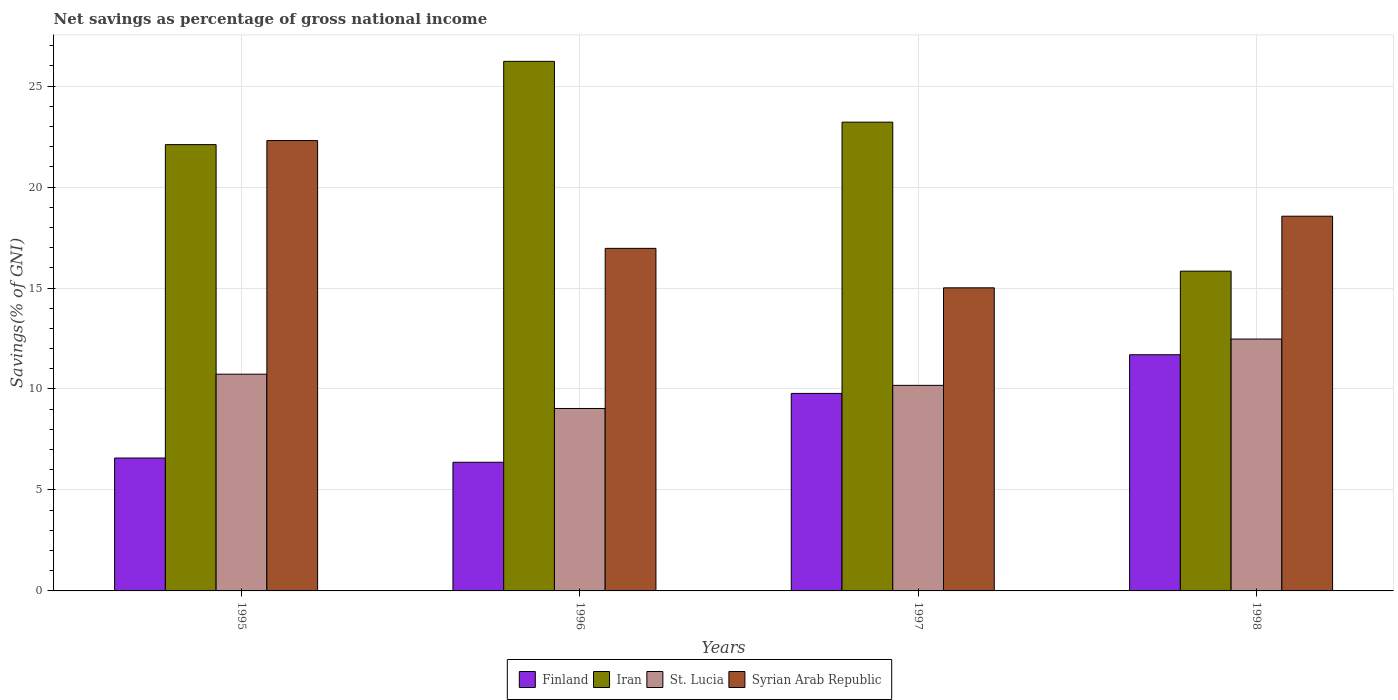How many different coloured bars are there?
Provide a short and direct response. 4. Are the number of bars per tick equal to the number of legend labels?
Your answer should be very brief. Yes. How many bars are there on the 1st tick from the right?
Make the answer very short. 4. What is the label of the 4th group of bars from the left?
Keep it short and to the point. 1998. What is the total savings in St. Lucia in 1998?
Give a very brief answer. 12.47. Across all years, what is the maximum total savings in St. Lucia?
Give a very brief answer. 12.47. Across all years, what is the minimum total savings in Iran?
Provide a succinct answer. 15.84. In which year was the total savings in St. Lucia maximum?
Keep it short and to the point. 1998. In which year was the total savings in Finland minimum?
Ensure brevity in your answer.  1996. What is the total total savings in Iran in the graph?
Your answer should be very brief. 87.38. What is the difference between the total savings in Iran in 1997 and that in 1998?
Keep it short and to the point. 7.38. What is the difference between the total savings in Syrian Arab Republic in 1998 and the total savings in Finland in 1997?
Your answer should be very brief. 8.78. What is the average total savings in Syrian Arab Republic per year?
Provide a succinct answer. 18.21. In the year 1995, what is the difference between the total savings in Finland and total savings in Syrian Arab Republic?
Give a very brief answer. -15.72. In how many years, is the total savings in St. Lucia greater than 14 %?
Offer a terse response. 0. What is the ratio of the total savings in Syrian Arab Republic in 1996 to that in 1997?
Offer a very short reply. 1.13. Is the total savings in Finland in 1995 less than that in 1997?
Provide a short and direct response. Yes. Is the difference between the total savings in Finland in 1995 and 1997 greater than the difference between the total savings in Syrian Arab Republic in 1995 and 1997?
Your answer should be very brief. No. What is the difference between the highest and the second highest total savings in Syrian Arab Republic?
Offer a terse response. 3.74. What is the difference between the highest and the lowest total savings in Syrian Arab Republic?
Offer a terse response. 7.29. Is the sum of the total savings in Finland in 1995 and 1998 greater than the maximum total savings in Syrian Arab Republic across all years?
Make the answer very short. No. Is it the case that in every year, the sum of the total savings in Iran and total savings in St. Lucia is greater than the sum of total savings in Finland and total savings in Syrian Arab Republic?
Offer a very short reply. No. What does the 4th bar from the left in 1995 represents?
Your answer should be very brief. Syrian Arab Republic. What does the 4th bar from the right in 1998 represents?
Offer a very short reply. Finland. How many bars are there?
Your response must be concise. 16. Are all the bars in the graph horizontal?
Your answer should be compact. No. Does the graph contain any zero values?
Your answer should be very brief. No. Does the graph contain grids?
Your answer should be very brief. Yes. How many legend labels are there?
Make the answer very short. 4. How are the legend labels stacked?
Your answer should be very brief. Horizontal. What is the title of the graph?
Offer a very short reply. Net savings as percentage of gross national income. Does "Greenland" appear as one of the legend labels in the graph?
Make the answer very short. No. What is the label or title of the X-axis?
Ensure brevity in your answer.  Years. What is the label or title of the Y-axis?
Keep it short and to the point. Savings(% of GNI). What is the Savings(% of GNI) in Finland in 1995?
Make the answer very short. 6.58. What is the Savings(% of GNI) of Iran in 1995?
Offer a very short reply. 22.1. What is the Savings(% of GNI) of St. Lucia in 1995?
Your answer should be compact. 10.73. What is the Savings(% of GNI) of Syrian Arab Republic in 1995?
Your answer should be very brief. 22.3. What is the Savings(% of GNI) of Finland in 1996?
Give a very brief answer. 6.37. What is the Savings(% of GNI) in Iran in 1996?
Offer a terse response. 26.23. What is the Savings(% of GNI) of St. Lucia in 1996?
Offer a terse response. 9.04. What is the Savings(% of GNI) of Syrian Arab Republic in 1996?
Make the answer very short. 16.96. What is the Savings(% of GNI) in Finland in 1997?
Offer a very short reply. 9.78. What is the Savings(% of GNI) in Iran in 1997?
Your answer should be very brief. 23.21. What is the Savings(% of GNI) in St. Lucia in 1997?
Provide a succinct answer. 10.18. What is the Savings(% of GNI) of Syrian Arab Republic in 1997?
Keep it short and to the point. 15.01. What is the Savings(% of GNI) of Finland in 1998?
Make the answer very short. 11.7. What is the Savings(% of GNI) in Iran in 1998?
Offer a terse response. 15.84. What is the Savings(% of GNI) of St. Lucia in 1998?
Offer a very short reply. 12.47. What is the Savings(% of GNI) of Syrian Arab Republic in 1998?
Ensure brevity in your answer.  18.56. Across all years, what is the maximum Savings(% of GNI) in Finland?
Make the answer very short. 11.7. Across all years, what is the maximum Savings(% of GNI) in Iran?
Offer a very short reply. 26.23. Across all years, what is the maximum Savings(% of GNI) in St. Lucia?
Provide a short and direct response. 12.47. Across all years, what is the maximum Savings(% of GNI) of Syrian Arab Republic?
Provide a short and direct response. 22.3. Across all years, what is the minimum Savings(% of GNI) in Finland?
Your answer should be compact. 6.37. Across all years, what is the minimum Savings(% of GNI) in Iran?
Give a very brief answer. 15.84. Across all years, what is the minimum Savings(% of GNI) in St. Lucia?
Provide a succinct answer. 9.04. Across all years, what is the minimum Savings(% of GNI) of Syrian Arab Republic?
Provide a succinct answer. 15.01. What is the total Savings(% of GNI) of Finland in the graph?
Your answer should be very brief. 34.43. What is the total Savings(% of GNI) of Iran in the graph?
Give a very brief answer. 87.38. What is the total Savings(% of GNI) in St. Lucia in the graph?
Offer a terse response. 42.42. What is the total Savings(% of GNI) in Syrian Arab Republic in the graph?
Offer a very short reply. 72.83. What is the difference between the Savings(% of GNI) in Finland in 1995 and that in 1996?
Your answer should be compact. 0.21. What is the difference between the Savings(% of GNI) of Iran in 1995 and that in 1996?
Offer a very short reply. -4.12. What is the difference between the Savings(% of GNI) in St. Lucia in 1995 and that in 1996?
Offer a terse response. 1.7. What is the difference between the Savings(% of GNI) in Syrian Arab Republic in 1995 and that in 1996?
Give a very brief answer. 5.34. What is the difference between the Savings(% of GNI) in Finland in 1995 and that in 1997?
Provide a succinct answer. -3.2. What is the difference between the Savings(% of GNI) in Iran in 1995 and that in 1997?
Provide a short and direct response. -1.11. What is the difference between the Savings(% of GNI) in St. Lucia in 1995 and that in 1997?
Offer a very short reply. 0.55. What is the difference between the Savings(% of GNI) of Syrian Arab Republic in 1995 and that in 1997?
Offer a very short reply. 7.29. What is the difference between the Savings(% of GNI) of Finland in 1995 and that in 1998?
Give a very brief answer. -5.12. What is the difference between the Savings(% of GNI) in Iran in 1995 and that in 1998?
Your response must be concise. 6.27. What is the difference between the Savings(% of GNI) of St. Lucia in 1995 and that in 1998?
Provide a short and direct response. -1.74. What is the difference between the Savings(% of GNI) in Syrian Arab Republic in 1995 and that in 1998?
Your response must be concise. 3.74. What is the difference between the Savings(% of GNI) in Finland in 1996 and that in 1997?
Your answer should be very brief. -3.41. What is the difference between the Savings(% of GNI) in Iran in 1996 and that in 1997?
Provide a short and direct response. 3.01. What is the difference between the Savings(% of GNI) of St. Lucia in 1996 and that in 1997?
Your response must be concise. -1.14. What is the difference between the Savings(% of GNI) of Syrian Arab Republic in 1996 and that in 1997?
Offer a terse response. 1.95. What is the difference between the Savings(% of GNI) of Finland in 1996 and that in 1998?
Provide a succinct answer. -5.32. What is the difference between the Savings(% of GNI) of Iran in 1996 and that in 1998?
Your answer should be very brief. 10.39. What is the difference between the Savings(% of GNI) in St. Lucia in 1996 and that in 1998?
Your response must be concise. -3.44. What is the difference between the Savings(% of GNI) in Syrian Arab Republic in 1996 and that in 1998?
Your answer should be very brief. -1.59. What is the difference between the Savings(% of GNI) in Finland in 1997 and that in 1998?
Ensure brevity in your answer.  -1.91. What is the difference between the Savings(% of GNI) in Iran in 1997 and that in 1998?
Provide a succinct answer. 7.38. What is the difference between the Savings(% of GNI) of St. Lucia in 1997 and that in 1998?
Provide a succinct answer. -2.29. What is the difference between the Savings(% of GNI) of Syrian Arab Republic in 1997 and that in 1998?
Make the answer very short. -3.55. What is the difference between the Savings(% of GNI) of Finland in 1995 and the Savings(% of GNI) of Iran in 1996?
Keep it short and to the point. -19.64. What is the difference between the Savings(% of GNI) in Finland in 1995 and the Savings(% of GNI) in St. Lucia in 1996?
Your answer should be very brief. -2.45. What is the difference between the Savings(% of GNI) in Finland in 1995 and the Savings(% of GNI) in Syrian Arab Republic in 1996?
Provide a succinct answer. -10.38. What is the difference between the Savings(% of GNI) of Iran in 1995 and the Savings(% of GNI) of St. Lucia in 1996?
Your answer should be compact. 13.07. What is the difference between the Savings(% of GNI) of Iran in 1995 and the Savings(% of GNI) of Syrian Arab Republic in 1996?
Your answer should be very brief. 5.14. What is the difference between the Savings(% of GNI) of St. Lucia in 1995 and the Savings(% of GNI) of Syrian Arab Republic in 1996?
Your answer should be compact. -6.23. What is the difference between the Savings(% of GNI) of Finland in 1995 and the Savings(% of GNI) of Iran in 1997?
Offer a terse response. -16.63. What is the difference between the Savings(% of GNI) in Finland in 1995 and the Savings(% of GNI) in St. Lucia in 1997?
Provide a succinct answer. -3.6. What is the difference between the Savings(% of GNI) of Finland in 1995 and the Savings(% of GNI) of Syrian Arab Republic in 1997?
Your response must be concise. -8.43. What is the difference between the Savings(% of GNI) in Iran in 1995 and the Savings(% of GNI) in St. Lucia in 1997?
Keep it short and to the point. 11.92. What is the difference between the Savings(% of GNI) in Iran in 1995 and the Savings(% of GNI) in Syrian Arab Republic in 1997?
Make the answer very short. 7.09. What is the difference between the Savings(% of GNI) in St. Lucia in 1995 and the Savings(% of GNI) in Syrian Arab Republic in 1997?
Offer a terse response. -4.28. What is the difference between the Savings(% of GNI) of Finland in 1995 and the Savings(% of GNI) of Iran in 1998?
Provide a short and direct response. -9.25. What is the difference between the Savings(% of GNI) of Finland in 1995 and the Savings(% of GNI) of St. Lucia in 1998?
Keep it short and to the point. -5.89. What is the difference between the Savings(% of GNI) of Finland in 1995 and the Savings(% of GNI) of Syrian Arab Republic in 1998?
Provide a short and direct response. -11.98. What is the difference between the Savings(% of GNI) in Iran in 1995 and the Savings(% of GNI) in St. Lucia in 1998?
Provide a short and direct response. 9.63. What is the difference between the Savings(% of GNI) in Iran in 1995 and the Savings(% of GNI) in Syrian Arab Republic in 1998?
Provide a short and direct response. 3.55. What is the difference between the Savings(% of GNI) in St. Lucia in 1995 and the Savings(% of GNI) in Syrian Arab Republic in 1998?
Your answer should be very brief. -7.82. What is the difference between the Savings(% of GNI) of Finland in 1996 and the Savings(% of GNI) of Iran in 1997?
Keep it short and to the point. -16.84. What is the difference between the Savings(% of GNI) of Finland in 1996 and the Savings(% of GNI) of St. Lucia in 1997?
Provide a short and direct response. -3.81. What is the difference between the Savings(% of GNI) in Finland in 1996 and the Savings(% of GNI) in Syrian Arab Republic in 1997?
Provide a succinct answer. -8.64. What is the difference between the Savings(% of GNI) in Iran in 1996 and the Savings(% of GNI) in St. Lucia in 1997?
Provide a short and direct response. 16.05. What is the difference between the Savings(% of GNI) of Iran in 1996 and the Savings(% of GNI) of Syrian Arab Republic in 1997?
Give a very brief answer. 11.22. What is the difference between the Savings(% of GNI) of St. Lucia in 1996 and the Savings(% of GNI) of Syrian Arab Republic in 1997?
Provide a succinct answer. -5.97. What is the difference between the Savings(% of GNI) in Finland in 1996 and the Savings(% of GNI) in Iran in 1998?
Provide a succinct answer. -9.46. What is the difference between the Savings(% of GNI) of Finland in 1996 and the Savings(% of GNI) of St. Lucia in 1998?
Give a very brief answer. -6.1. What is the difference between the Savings(% of GNI) of Finland in 1996 and the Savings(% of GNI) of Syrian Arab Republic in 1998?
Provide a short and direct response. -12.19. What is the difference between the Savings(% of GNI) of Iran in 1996 and the Savings(% of GNI) of St. Lucia in 1998?
Ensure brevity in your answer.  13.75. What is the difference between the Savings(% of GNI) of Iran in 1996 and the Savings(% of GNI) of Syrian Arab Republic in 1998?
Provide a succinct answer. 7.67. What is the difference between the Savings(% of GNI) in St. Lucia in 1996 and the Savings(% of GNI) in Syrian Arab Republic in 1998?
Give a very brief answer. -9.52. What is the difference between the Savings(% of GNI) of Finland in 1997 and the Savings(% of GNI) of Iran in 1998?
Offer a terse response. -6.05. What is the difference between the Savings(% of GNI) of Finland in 1997 and the Savings(% of GNI) of St. Lucia in 1998?
Give a very brief answer. -2.69. What is the difference between the Savings(% of GNI) of Finland in 1997 and the Savings(% of GNI) of Syrian Arab Republic in 1998?
Offer a very short reply. -8.78. What is the difference between the Savings(% of GNI) in Iran in 1997 and the Savings(% of GNI) in St. Lucia in 1998?
Ensure brevity in your answer.  10.74. What is the difference between the Savings(% of GNI) of Iran in 1997 and the Savings(% of GNI) of Syrian Arab Republic in 1998?
Provide a short and direct response. 4.66. What is the difference between the Savings(% of GNI) in St. Lucia in 1997 and the Savings(% of GNI) in Syrian Arab Republic in 1998?
Provide a short and direct response. -8.38. What is the average Savings(% of GNI) of Finland per year?
Provide a succinct answer. 8.61. What is the average Savings(% of GNI) of Iran per year?
Provide a succinct answer. 21.84. What is the average Savings(% of GNI) of St. Lucia per year?
Your answer should be compact. 10.61. What is the average Savings(% of GNI) of Syrian Arab Republic per year?
Offer a very short reply. 18.21. In the year 1995, what is the difference between the Savings(% of GNI) in Finland and Savings(% of GNI) in Iran?
Offer a terse response. -15.52. In the year 1995, what is the difference between the Savings(% of GNI) in Finland and Savings(% of GNI) in St. Lucia?
Offer a very short reply. -4.15. In the year 1995, what is the difference between the Savings(% of GNI) of Finland and Savings(% of GNI) of Syrian Arab Republic?
Your answer should be very brief. -15.72. In the year 1995, what is the difference between the Savings(% of GNI) of Iran and Savings(% of GNI) of St. Lucia?
Provide a succinct answer. 11.37. In the year 1995, what is the difference between the Savings(% of GNI) of Iran and Savings(% of GNI) of Syrian Arab Republic?
Give a very brief answer. -0.2. In the year 1995, what is the difference between the Savings(% of GNI) of St. Lucia and Savings(% of GNI) of Syrian Arab Republic?
Provide a succinct answer. -11.57. In the year 1996, what is the difference between the Savings(% of GNI) in Finland and Savings(% of GNI) in Iran?
Your answer should be compact. -19.85. In the year 1996, what is the difference between the Savings(% of GNI) in Finland and Savings(% of GNI) in St. Lucia?
Offer a very short reply. -2.66. In the year 1996, what is the difference between the Savings(% of GNI) of Finland and Savings(% of GNI) of Syrian Arab Republic?
Your answer should be very brief. -10.59. In the year 1996, what is the difference between the Savings(% of GNI) of Iran and Savings(% of GNI) of St. Lucia?
Your answer should be compact. 17.19. In the year 1996, what is the difference between the Savings(% of GNI) in Iran and Savings(% of GNI) in Syrian Arab Republic?
Your answer should be very brief. 9.26. In the year 1996, what is the difference between the Savings(% of GNI) of St. Lucia and Savings(% of GNI) of Syrian Arab Republic?
Keep it short and to the point. -7.93. In the year 1997, what is the difference between the Savings(% of GNI) in Finland and Savings(% of GNI) in Iran?
Offer a very short reply. -13.43. In the year 1997, what is the difference between the Savings(% of GNI) in Finland and Savings(% of GNI) in St. Lucia?
Keep it short and to the point. -0.4. In the year 1997, what is the difference between the Savings(% of GNI) in Finland and Savings(% of GNI) in Syrian Arab Republic?
Your answer should be compact. -5.23. In the year 1997, what is the difference between the Savings(% of GNI) of Iran and Savings(% of GNI) of St. Lucia?
Your response must be concise. 13.03. In the year 1997, what is the difference between the Savings(% of GNI) of Iran and Savings(% of GNI) of Syrian Arab Republic?
Keep it short and to the point. 8.2. In the year 1997, what is the difference between the Savings(% of GNI) in St. Lucia and Savings(% of GNI) in Syrian Arab Republic?
Ensure brevity in your answer.  -4.83. In the year 1998, what is the difference between the Savings(% of GNI) in Finland and Savings(% of GNI) in Iran?
Offer a terse response. -4.14. In the year 1998, what is the difference between the Savings(% of GNI) in Finland and Savings(% of GNI) in St. Lucia?
Provide a succinct answer. -0.78. In the year 1998, what is the difference between the Savings(% of GNI) in Finland and Savings(% of GNI) in Syrian Arab Republic?
Keep it short and to the point. -6.86. In the year 1998, what is the difference between the Savings(% of GNI) of Iran and Savings(% of GNI) of St. Lucia?
Ensure brevity in your answer.  3.36. In the year 1998, what is the difference between the Savings(% of GNI) of Iran and Savings(% of GNI) of Syrian Arab Republic?
Keep it short and to the point. -2.72. In the year 1998, what is the difference between the Savings(% of GNI) of St. Lucia and Savings(% of GNI) of Syrian Arab Republic?
Ensure brevity in your answer.  -6.08. What is the ratio of the Savings(% of GNI) in Finland in 1995 to that in 1996?
Your answer should be very brief. 1.03. What is the ratio of the Savings(% of GNI) in Iran in 1995 to that in 1996?
Ensure brevity in your answer.  0.84. What is the ratio of the Savings(% of GNI) in St. Lucia in 1995 to that in 1996?
Your answer should be very brief. 1.19. What is the ratio of the Savings(% of GNI) of Syrian Arab Republic in 1995 to that in 1996?
Ensure brevity in your answer.  1.31. What is the ratio of the Savings(% of GNI) in Finland in 1995 to that in 1997?
Your response must be concise. 0.67. What is the ratio of the Savings(% of GNI) in Iran in 1995 to that in 1997?
Offer a terse response. 0.95. What is the ratio of the Savings(% of GNI) in St. Lucia in 1995 to that in 1997?
Your answer should be compact. 1.05. What is the ratio of the Savings(% of GNI) of Syrian Arab Republic in 1995 to that in 1997?
Provide a short and direct response. 1.49. What is the ratio of the Savings(% of GNI) in Finland in 1995 to that in 1998?
Your response must be concise. 0.56. What is the ratio of the Savings(% of GNI) of Iran in 1995 to that in 1998?
Offer a terse response. 1.4. What is the ratio of the Savings(% of GNI) in St. Lucia in 1995 to that in 1998?
Your response must be concise. 0.86. What is the ratio of the Savings(% of GNI) of Syrian Arab Republic in 1995 to that in 1998?
Your answer should be very brief. 1.2. What is the ratio of the Savings(% of GNI) of Finland in 1996 to that in 1997?
Offer a very short reply. 0.65. What is the ratio of the Savings(% of GNI) in Iran in 1996 to that in 1997?
Give a very brief answer. 1.13. What is the ratio of the Savings(% of GNI) of St. Lucia in 1996 to that in 1997?
Your answer should be very brief. 0.89. What is the ratio of the Savings(% of GNI) of Syrian Arab Republic in 1996 to that in 1997?
Keep it short and to the point. 1.13. What is the ratio of the Savings(% of GNI) of Finland in 1996 to that in 1998?
Your response must be concise. 0.54. What is the ratio of the Savings(% of GNI) in Iran in 1996 to that in 1998?
Your response must be concise. 1.66. What is the ratio of the Savings(% of GNI) in St. Lucia in 1996 to that in 1998?
Ensure brevity in your answer.  0.72. What is the ratio of the Savings(% of GNI) of Syrian Arab Republic in 1996 to that in 1998?
Provide a succinct answer. 0.91. What is the ratio of the Savings(% of GNI) in Finland in 1997 to that in 1998?
Your answer should be very brief. 0.84. What is the ratio of the Savings(% of GNI) in Iran in 1997 to that in 1998?
Provide a succinct answer. 1.47. What is the ratio of the Savings(% of GNI) in St. Lucia in 1997 to that in 1998?
Offer a very short reply. 0.82. What is the ratio of the Savings(% of GNI) of Syrian Arab Republic in 1997 to that in 1998?
Give a very brief answer. 0.81. What is the difference between the highest and the second highest Savings(% of GNI) of Finland?
Offer a very short reply. 1.91. What is the difference between the highest and the second highest Savings(% of GNI) in Iran?
Provide a short and direct response. 3.01. What is the difference between the highest and the second highest Savings(% of GNI) in St. Lucia?
Provide a succinct answer. 1.74. What is the difference between the highest and the second highest Savings(% of GNI) in Syrian Arab Republic?
Ensure brevity in your answer.  3.74. What is the difference between the highest and the lowest Savings(% of GNI) in Finland?
Your answer should be very brief. 5.32. What is the difference between the highest and the lowest Savings(% of GNI) of Iran?
Ensure brevity in your answer.  10.39. What is the difference between the highest and the lowest Savings(% of GNI) in St. Lucia?
Make the answer very short. 3.44. What is the difference between the highest and the lowest Savings(% of GNI) in Syrian Arab Republic?
Your answer should be compact. 7.29. 